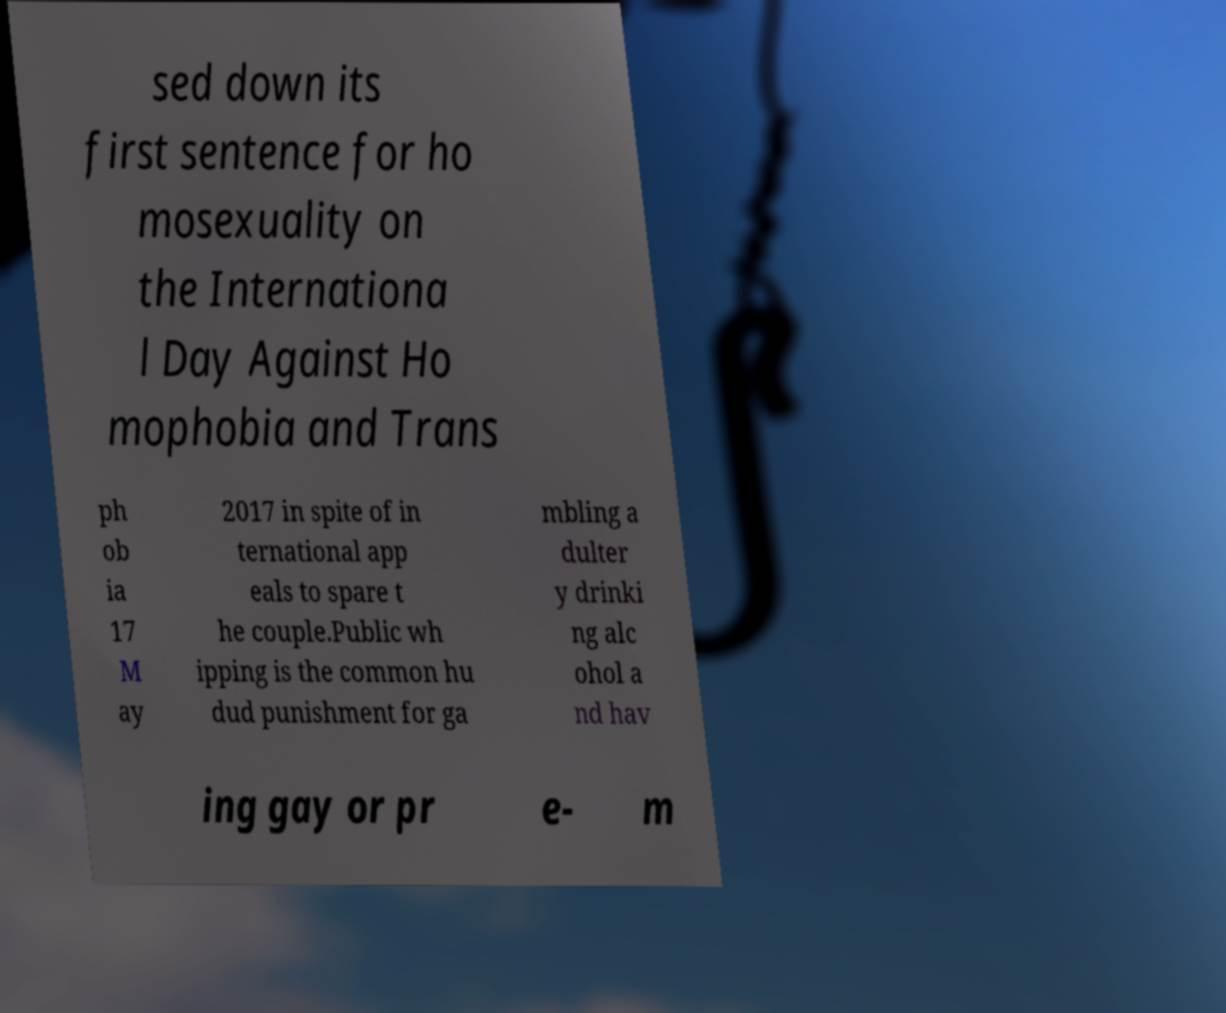Can you accurately transcribe the text from the provided image for me? sed down its first sentence for ho mosexuality on the Internationa l Day Against Ho mophobia and Trans ph ob ia 17 M ay 2017 in spite of in ternational app eals to spare t he couple.Public wh ipping is the common hu dud punishment for ga mbling a dulter y drinki ng alc ohol a nd hav ing gay or pr e- m 